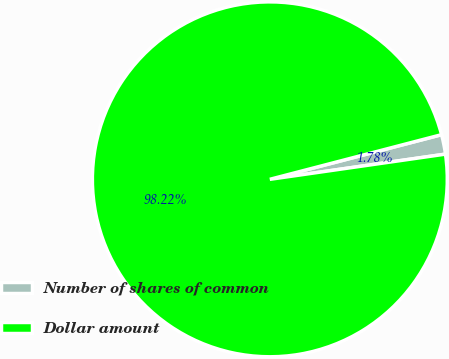Convert chart to OTSL. <chart><loc_0><loc_0><loc_500><loc_500><pie_chart><fcel>Number of shares of common<fcel>Dollar amount<nl><fcel>1.78%<fcel>98.22%<nl></chart> 